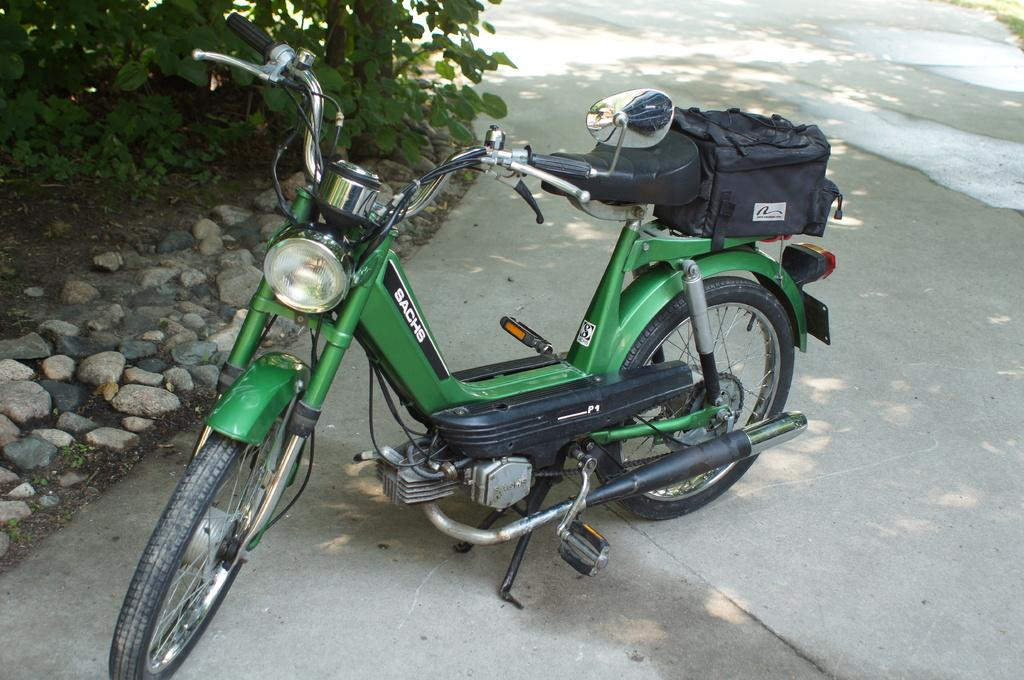What is the main object in the image? There is a bike in the image. What is the position of the bike in the image? The bike is on the ground. Is there any additional item attached to the bike? Yes, there is a bag on the bike. What type of natural elements can be seen in the image? There are stones and trees in the image. What type of cloth is being used to capture the battle scene in the image? There is no cloth or battle scene present in the image; it features a bike on the ground with a bag attached. Is there a camera visible in the image? There is no camera present in the image. 